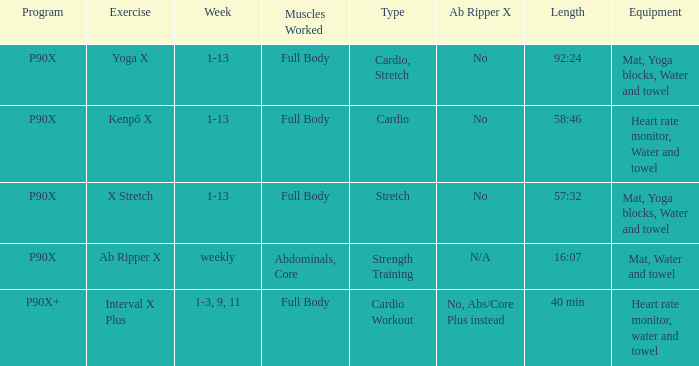What type of workout involves using a heart rate monitor, water, and a towel? Kenpō X, Interval X Plus. 